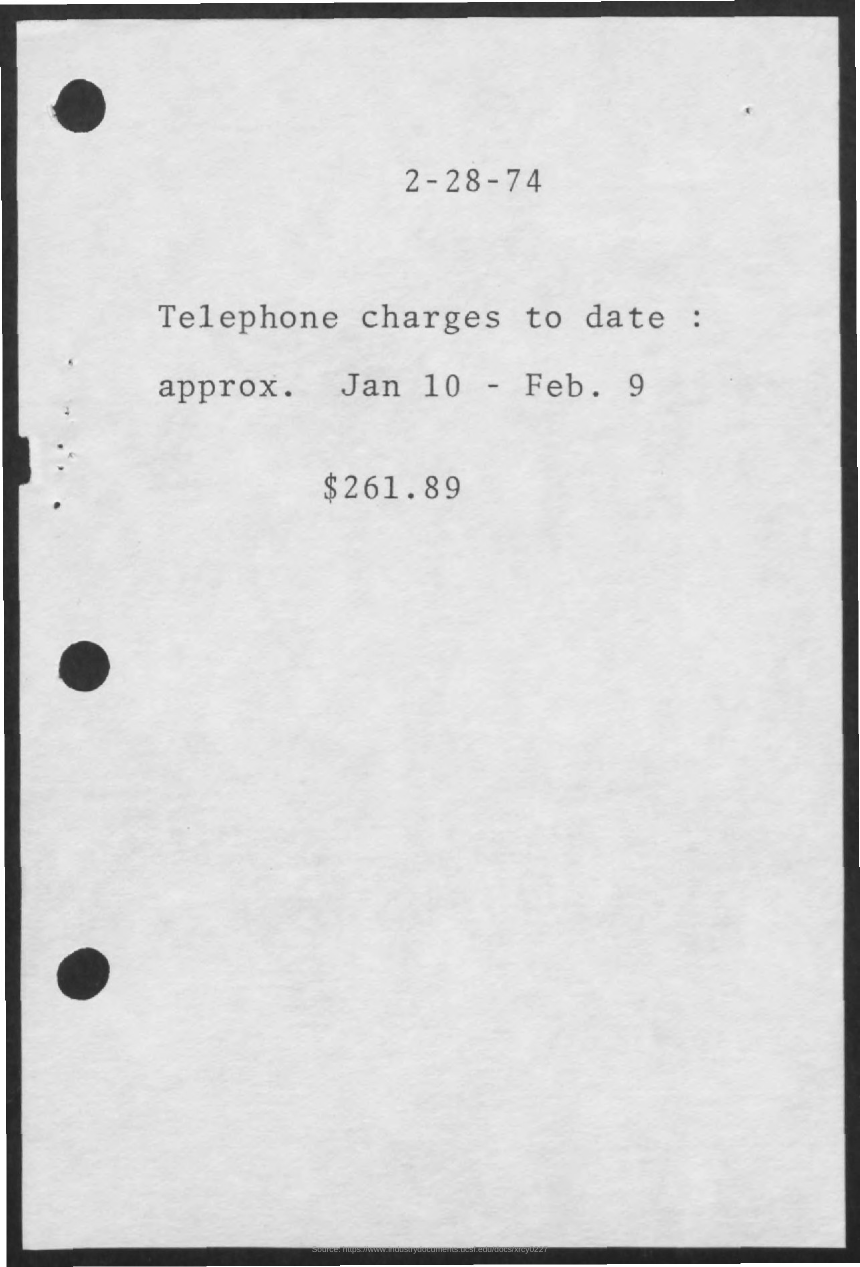What is total telephone charges?
 $261.89 